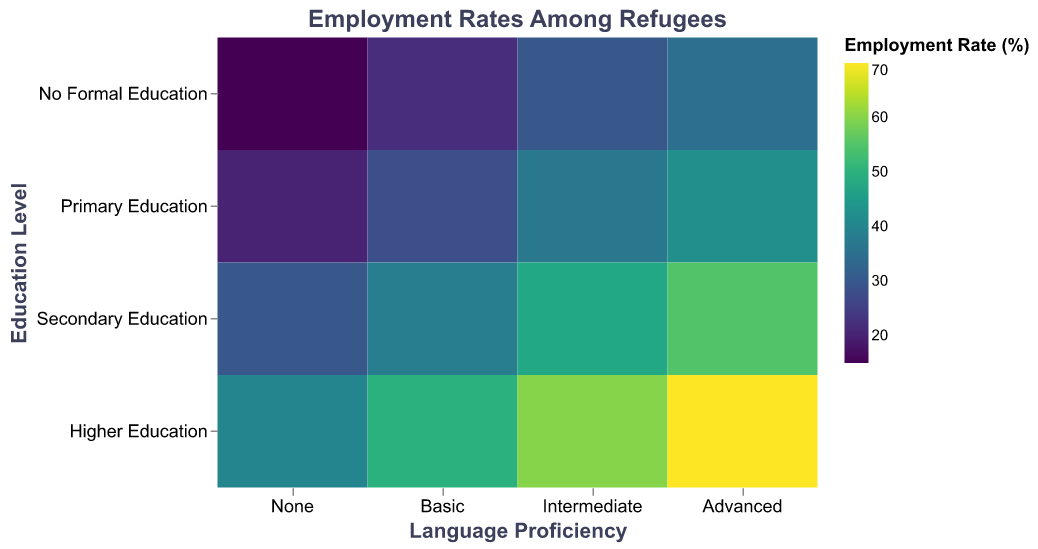What is the title of the heatmap? The title of the chart is displayed at the top center.
Answer: Employment Rates Among Refugees How is the highest employment rate distributed across education levels for advanced language proficiency? Check the cells corresponding to "Advanced" language proficiency across all education levels. "Higher Education" has the highest value at 70%.
Answer: Higher Education Which education level has the lowest employment rate for "Basic" language proficiency? Locate the column for "Basic" language proficiency and find the row with the smallest value. It corresponds to "No Formal Education," which has an employment rate of 22%.
Answer: No Formal Education By how much does employment rate increase from "None" to "Advanced" language proficiency for "No Formal Education"? Subtract the employment rate of "None" (15%) from "Advanced" (35%). The difference is 35% - 15% = 20%.
Answer: 20% What is the employment rate for refugees with "Primary Education" and "Intermediate" language proficiency? Look at the intersection of "Primary Education" row and "Intermediate" column. The value is 37%.
Answer: 37% Which combination of education level and language proficiency has the highest employment rate? Identify the cell with the highest value, which is "Higher Education" and "Advanced" language proficiency at 70%.
Answer: Higher Education, Advanced On average, how does the employment rate change with increased language proficiency for refugees with "Primary Education"? Calculate the average by adding employment rates for "None" (20%), "Basic" (28%), "Intermediate" (37%), and "Advanced" (42%) and then dividing by 4. The result is (20+28+37+42)/4 = 31.75%.
Answer: 31.75% Compare the employment rates of "Secondary Education" with "Basic" and "Intermediate" language proficiency. Which is higher, and by how much? Compare the values in "Secondary Education" row for "Basic" (38%) and "Intermediate" (48%) language proficiency. The difference is 48% - 38% = 10%.
Answer: Intermediate is higher by 10% Is there a trend in employment rates associated with increasing education levels for "None" language proficiency? Observe the cells in the "None" language proficiency column from "No Formal Education" to "Higher Education." The trend shows an increase: 15%, 20%, 30%, 40%.
Answer: Increasing trend 